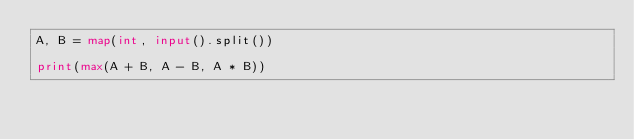Convert code to text. <code><loc_0><loc_0><loc_500><loc_500><_Python_>A, B = map(int, input().split())

print(max(A + B, A - B, A * B))
</code> 